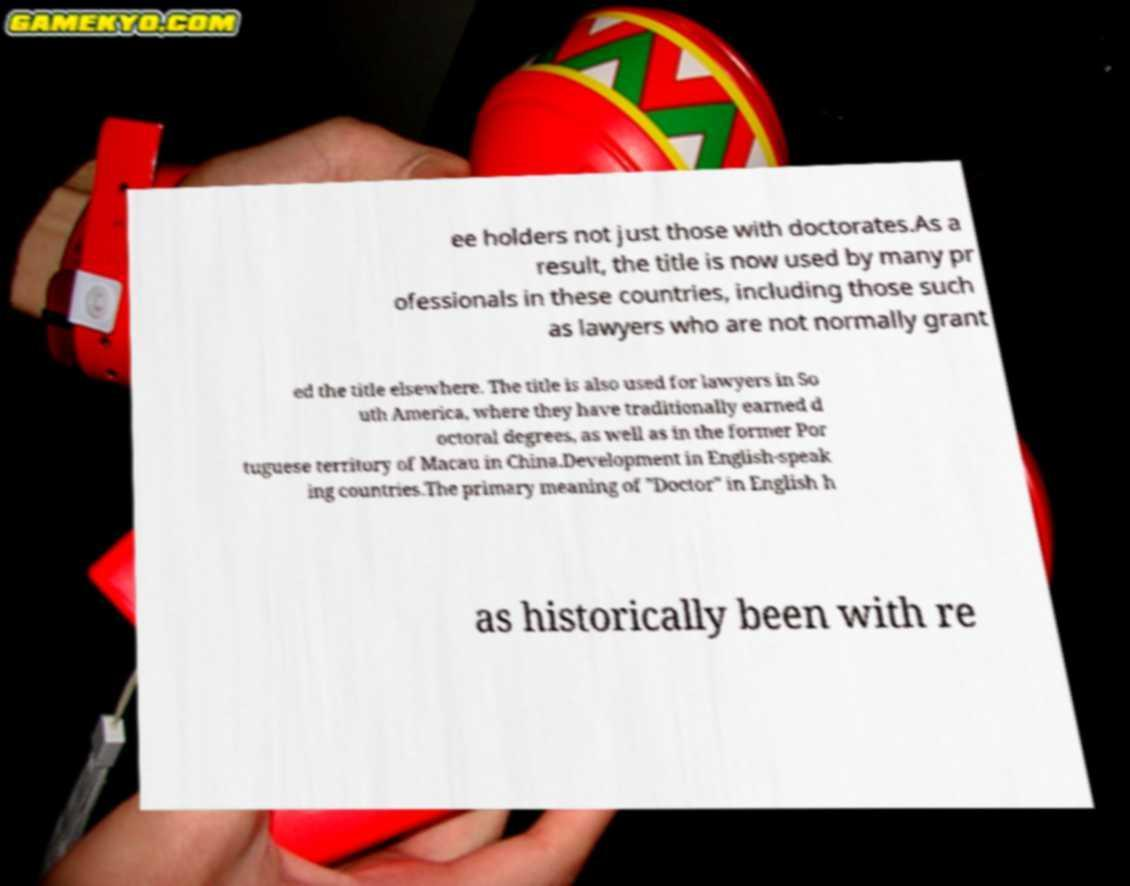Could you extract and type out the text from this image? ee holders not just those with doctorates.As a result, the title is now used by many pr ofessionals in these countries, including those such as lawyers who are not normally grant ed the title elsewhere. The title is also used for lawyers in So uth America, where they have traditionally earned d octoral degrees, as well as in the former Por tuguese territory of Macau in China.Development in English-speak ing countries.The primary meaning of "Doctor" in English h as historically been with re 